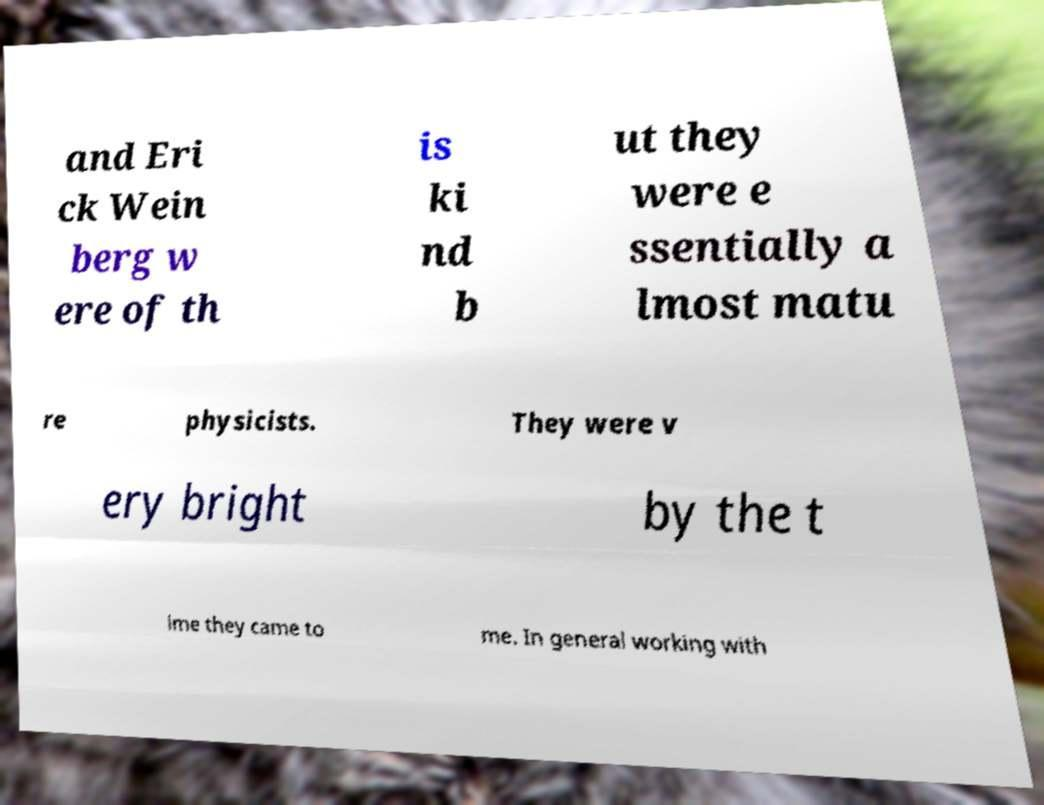What messages or text are displayed in this image? I need them in a readable, typed format. and Eri ck Wein berg w ere of th is ki nd b ut they were e ssentially a lmost matu re physicists. They were v ery bright by the t ime they came to me. In general working with 